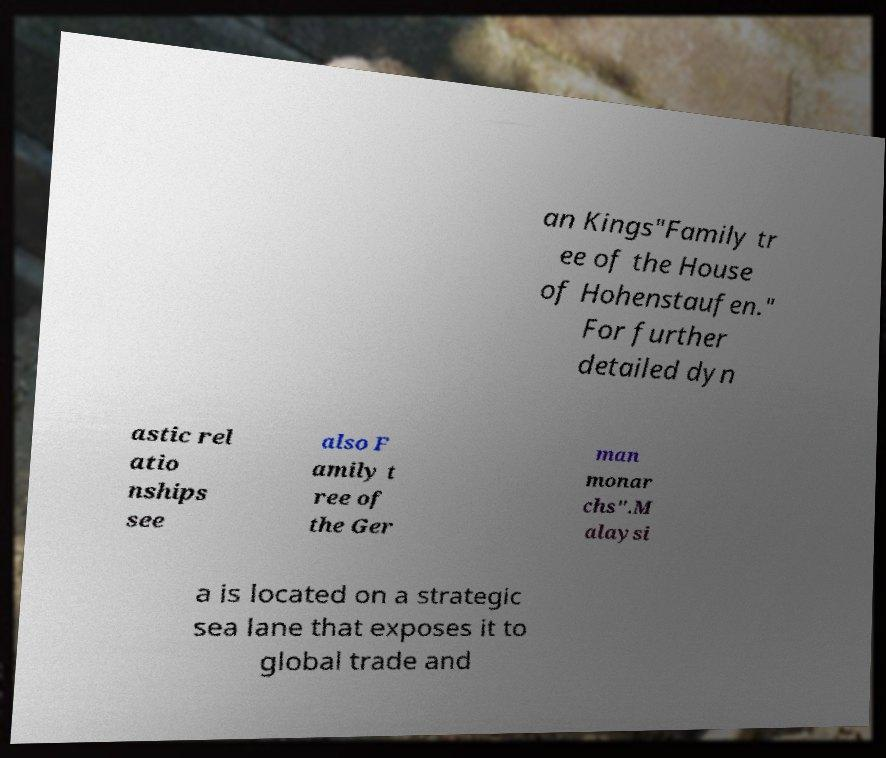Could you assist in decoding the text presented in this image and type it out clearly? an Kings"Family tr ee of the House of Hohenstaufen." For further detailed dyn astic rel atio nships see also F amily t ree of the Ger man monar chs".M alaysi a is located on a strategic sea lane that exposes it to global trade and 